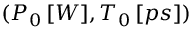<formula> <loc_0><loc_0><loc_500><loc_500>( P _ { 0 } \, [ W ] , T _ { 0 } \, [ p s ] )</formula> 